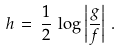<formula> <loc_0><loc_0><loc_500><loc_500>h \, = \, \frac { 1 } { 2 } \, \log \left | \frac { g } { f } \right | \, .</formula> 